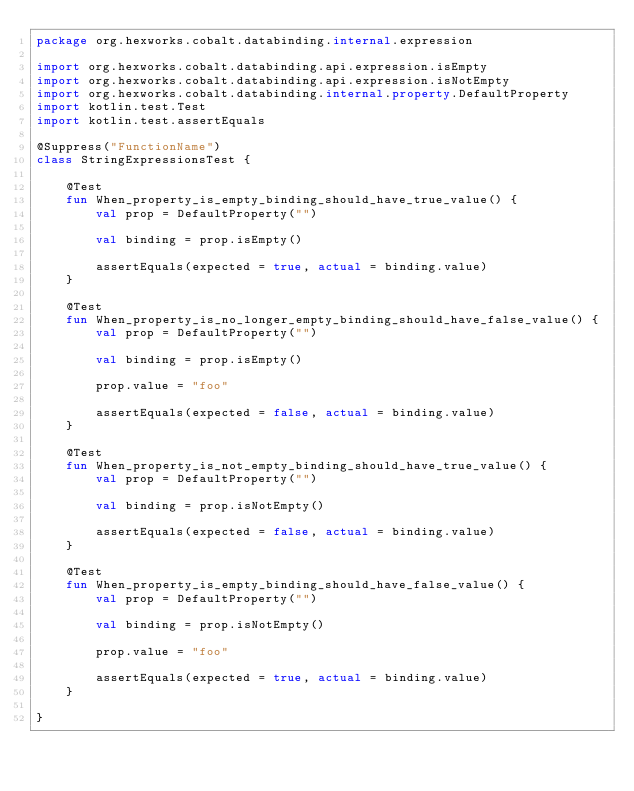Convert code to text. <code><loc_0><loc_0><loc_500><loc_500><_Kotlin_>package org.hexworks.cobalt.databinding.internal.expression

import org.hexworks.cobalt.databinding.api.expression.isEmpty
import org.hexworks.cobalt.databinding.api.expression.isNotEmpty
import org.hexworks.cobalt.databinding.internal.property.DefaultProperty
import kotlin.test.Test
import kotlin.test.assertEquals

@Suppress("FunctionName")
class StringExpressionsTest {

    @Test
    fun When_property_is_empty_binding_should_have_true_value() {
        val prop = DefaultProperty("")

        val binding = prop.isEmpty()

        assertEquals(expected = true, actual = binding.value)
    }

    @Test
    fun When_property_is_no_longer_empty_binding_should_have_false_value() {
        val prop = DefaultProperty("")

        val binding = prop.isEmpty()

        prop.value = "foo"

        assertEquals(expected = false, actual = binding.value)
    }

    @Test
    fun When_property_is_not_empty_binding_should_have_true_value() {
        val prop = DefaultProperty("")

        val binding = prop.isNotEmpty()

        assertEquals(expected = false, actual = binding.value)
    }

    @Test
    fun When_property_is_empty_binding_should_have_false_value() {
        val prop = DefaultProperty("")

        val binding = prop.isNotEmpty()

        prop.value = "foo"

        assertEquals(expected = true, actual = binding.value)
    }

}
</code> 